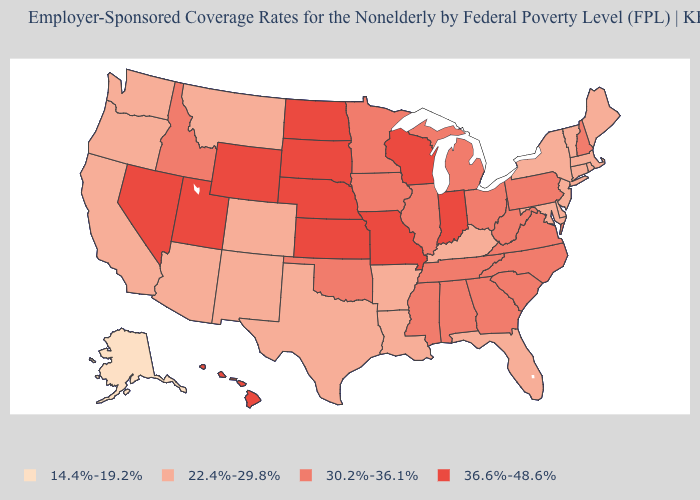Does Florida have a higher value than Montana?
Keep it brief. No. What is the value of Maine?
Answer briefly. 22.4%-29.8%. Among the states that border West Virginia , which have the highest value?
Give a very brief answer. Ohio, Pennsylvania, Virginia. What is the value of Connecticut?
Quick response, please. 22.4%-29.8%. Among the states that border Wisconsin , which have the lowest value?
Concise answer only. Illinois, Iowa, Michigan, Minnesota. What is the highest value in states that border Alabama?
Concise answer only. 30.2%-36.1%. What is the lowest value in states that border New Mexico?
Write a very short answer. 22.4%-29.8%. What is the value of Oklahoma?
Quick response, please. 30.2%-36.1%. What is the lowest value in the USA?
Write a very short answer. 14.4%-19.2%. Name the states that have a value in the range 36.6%-48.6%?
Concise answer only. Hawaii, Indiana, Kansas, Missouri, Nebraska, Nevada, North Dakota, South Dakota, Utah, Wisconsin, Wyoming. What is the lowest value in the Northeast?
Give a very brief answer. 22.4%-29.8%. What is the value of South Carolina?
Concise answer only. 30.2%-36.1%. Name the states that have a value in the range 22.4%-29.8%?
Be succinct. Arizona, Arkansas, California, Colorado, Connecticut, Delaware, Florida, Kentucky, Louisiana, Maine, Maryland, Massachusetts, Montana, New Jersey, New Mexico, New York, Oregon, Rhode Island, Texas, Vermont, Washington. Does Nebraska have the highest value in the USA?
Keep it brief. Yes. Does North Dakota have the highest value in the USA?
Quick response, please. Yes. 